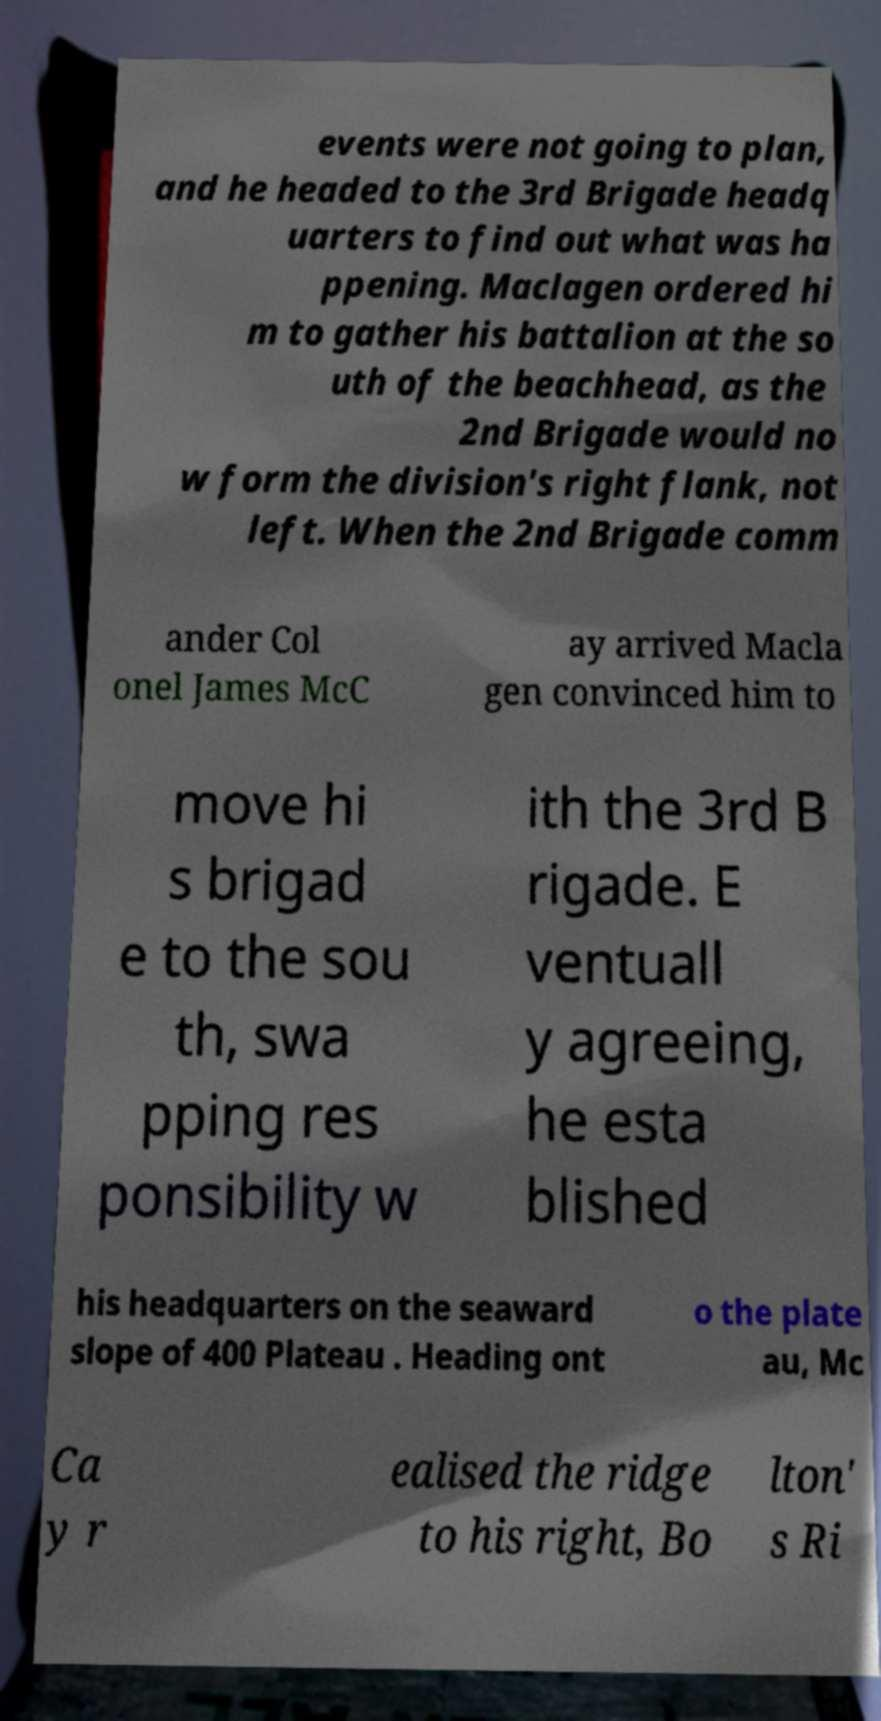Can you accurately transcribe the text from the provided image for me? events were not going to plan, and he headed to the 3rd Brigade headq uarters to find out what was ha ppening. Maclagen ordered hi m to gather his battalion at the so uth of the beachhead, as the 2nd Brigade would no w form the division's right flank, not left. When the 2nd Brigade comm ander Col onel James McC ay arrived Macla gen convinced him to move hi s brigad e to the sou th, swa pping res ponsibility w ith the 3rd B rigade. E ventuall y agreeing, he esta blished his headquarters on the seaward slope of 400 Plateau . Heading ont o the plate au, Mc Ca y r ealised the ridge to his right, Bo lton' s Ri 